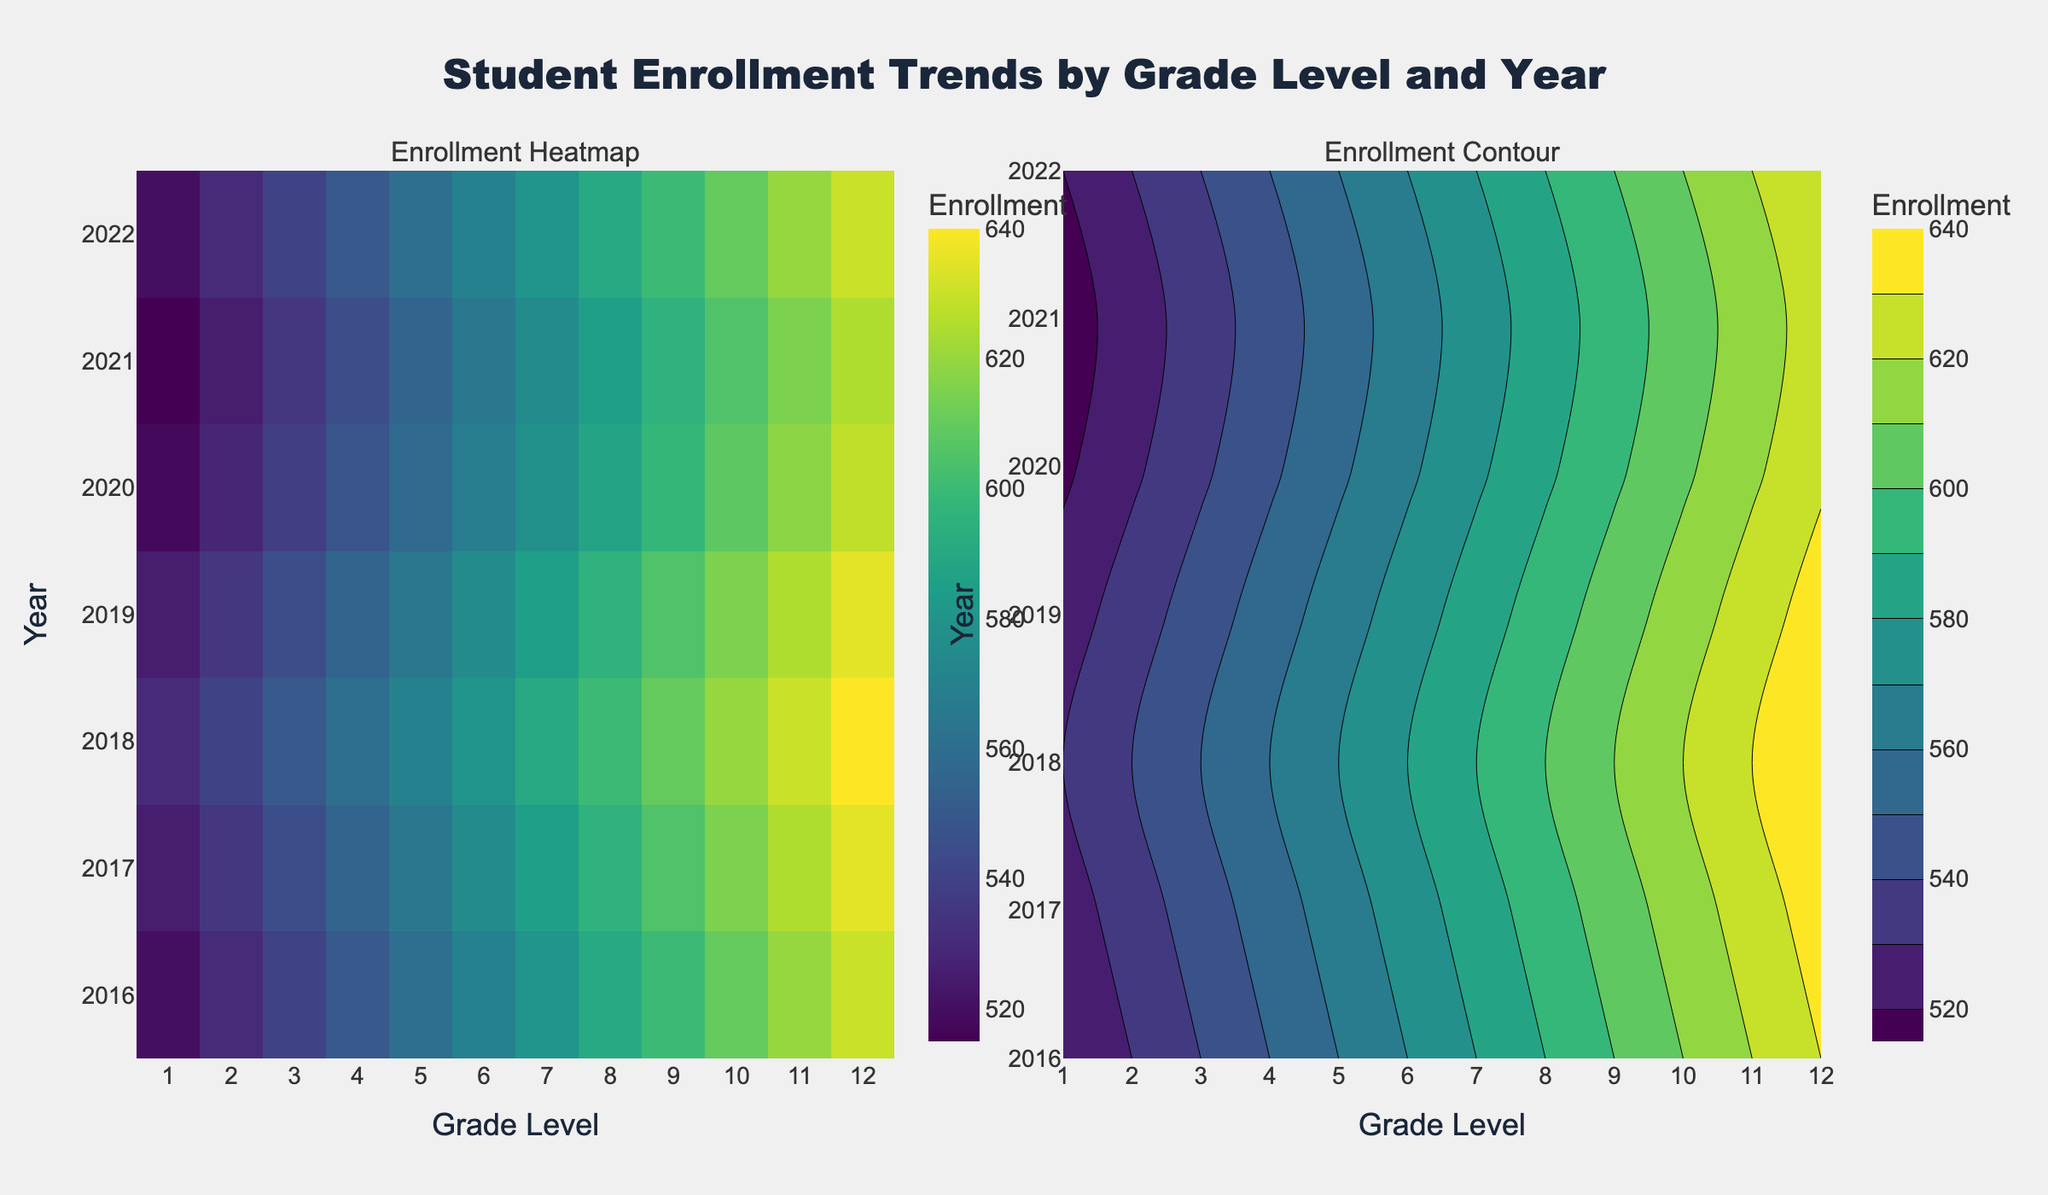What are the titles of the subplots? The titles of the subplots are evident from their placement above each plot. The left plot is titled "Enrollment Heatmap," and the right plot is titled "Enrollment Contour."
Answer: Enrollment Heatmap, Enrollment Contour What grade levels are represented in the plots? The grade levels can be identified from the x-axis labeled "Grade Level" on both subplots. They range from 1 to 12, covering all standard K-12 grade levels.
Answer: 1 to 12 How does enrollment in Grade 1 change from 2016 to 2022? To determine how enrollment changes in Grade 1, observe the data points along the Grade 1 line from 2016 to 2022. Enrollment slightly fluctuates from 520 in 2016 to 520 in 2022, after some minor variations.
Answer: Remains relatively constant around 520 Which year and grade level combination has the highest enrollment? The highest enrollment can be found by identifying the darkest region in the heatmap or the highest contour line in the contour plot. The maximum value is 640, which occurs in Grade 12 in 2018.
Answer: Grade 12 in 2018 What is the color scale used to represent enrollment? The color scale, observed from the color bars accompanying each subplot, is 'Viridis,' which transitions from dark blues to greens to yellows to signify increasing enrollment values.
Answer: Viridis Compare the enrollment trends for Grades 6 and 12 between 2016 and 2022. For Grades 6 and 12, track these lines across the years. Both show slight increases in enrollment over time. Grade 12 starts higher and increases more notably, while Grade 6 shows steady, less steep increments.
Answer: Both increase, but Grade 12 increases more significantly What is the overall trend in student enrollment from 2016 to 2022? Observing the y-axis trends of how the colors shift lighter toward higher grades and darker toward lower grades across years indicates an overall gradual increase in student enrollment.
Answer: Gradual increase What year had the largest decrease in enrollments across most grade levels? By comparing colors over years, the darkest-to-lighter shift happening between 2019 to 2021 indicates a decrease, making 2021 the year with significant enrollment drops compared to 2020 and 2022.
Answer: 2021 How does enrollment in Grade 9 compare between 2020 and 2021? By examining both plots, noting the value for Grade 9 in 2020 and 2021 indicates a decrease from 598 in 2020 to 595 in 2021.
Answer: Decreases from 598 to 595 How does the enrollment in 2017 compare to that of 2020 for Grade 5? To answer this, find the values for Grade 5 in 2017 and 2020 from either plot. Enrollment increases slightly from 565 in 2017 to 558 in 2020.
Answer: Decreases from 565 to 558 